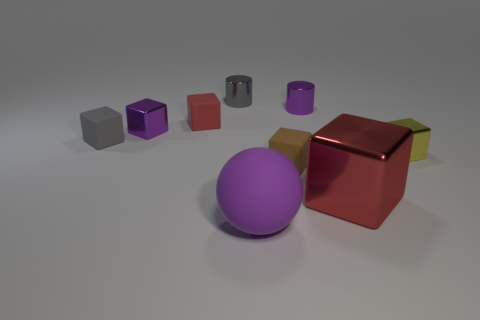Subtract all big red blocks. How many blocks are left? 5 Subtract all gray blocks. How many blocks are left? 5 Subtract all blue cubes. Subtract all red cylinders. How many cubes are left? 6 Add 1 tiny purple rubber things. How many objects exist? 10 Subtract all balls. How many objects are left? 8 Add 4 rubber spheres. How many rubber spheres exist? 5 Subtract 0 brown cylinders. How many objects are left? 9 Subtract all big blue metallic balls. Subtract all gray things. How many objects are left? 7 Add 5 matte objects. How many matte objects are left? 9 